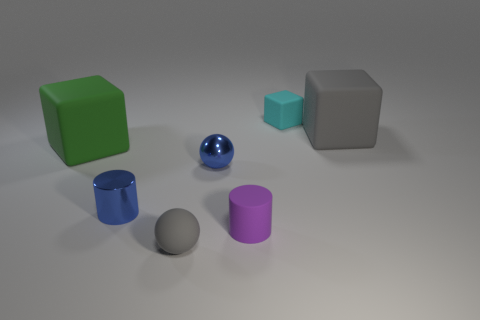What is the size of the sphere that is the same color as the shiny cylinder? The sphere sharing the same glossy blue color as the shiny cylinder is small in size, approximately a third of the cylinder's height. 